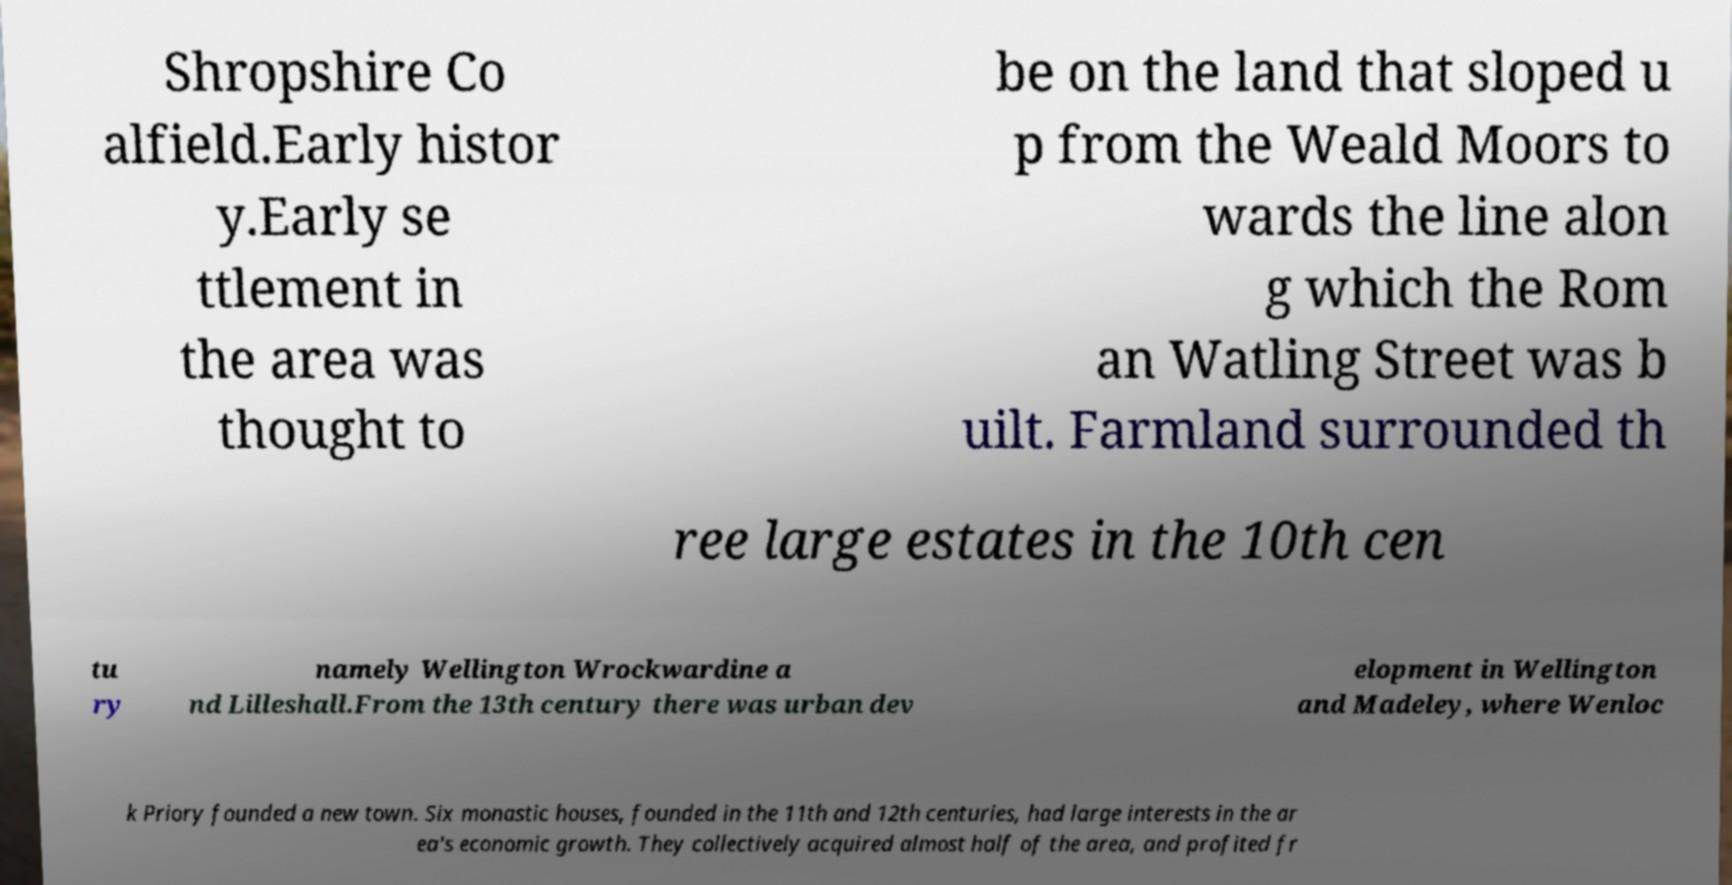Could you extract and type out the text from this image? Shropshire Co alfield.Early histor y.Early se ttlement in the area was thought to be on the land that sloped u p from the Weald Moors to wards the line alon g which the Rom an Watling Street was b uilt. Farmland surrounded th ree large estates in the 10th cen tu ry namely Wellington Wrockwardine a nd Lilleshall.From the 13th century there was urban dev elopment in Wellington and Madeley, where Wenloc k Priory founded a new town. Six monastic houses, founded in the 11th and 12th centuries, had large interests in the ar ea's economic growth. They collectively acquired almost half of the area, and profited fr 